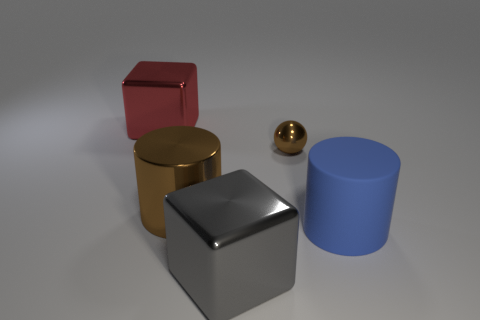Is the material of the cylinder that is on the left side of the big gray metallic block the same as the cylinder to the right of the brown sphere?
Offer a very short reply. No. How many big blue rubber cylinders are there?
Your response must be concise. 1. How many other big blue objects have the same shape as the large blue rubber object?
Your response must be concise. 0. Is the blue rubber object the same shape as the gray metal thing?
Offer a terse response. No. What is the size of the blue object?
Your response must be concise. Large. How many metal cylinders have the same size as the red metal object?
Provide a succinct answer. 1. There is a brown metal thing in front of the metal sphere; is its size the same as the brown metallic thing that is behind the large brown thing?
Your answer should be compact. No. There is a brown shiny thing that is in front of the small metallic ball; what is its shape?
Ensure brevity in your answer.  Cylinder. What material is the block that is behind the large shiny block in front of the red thing made of?
Provide a short and direct response. Metal. Is there another sphere that has the same color as the metallic ball?
Provide a short and direct response. No. 